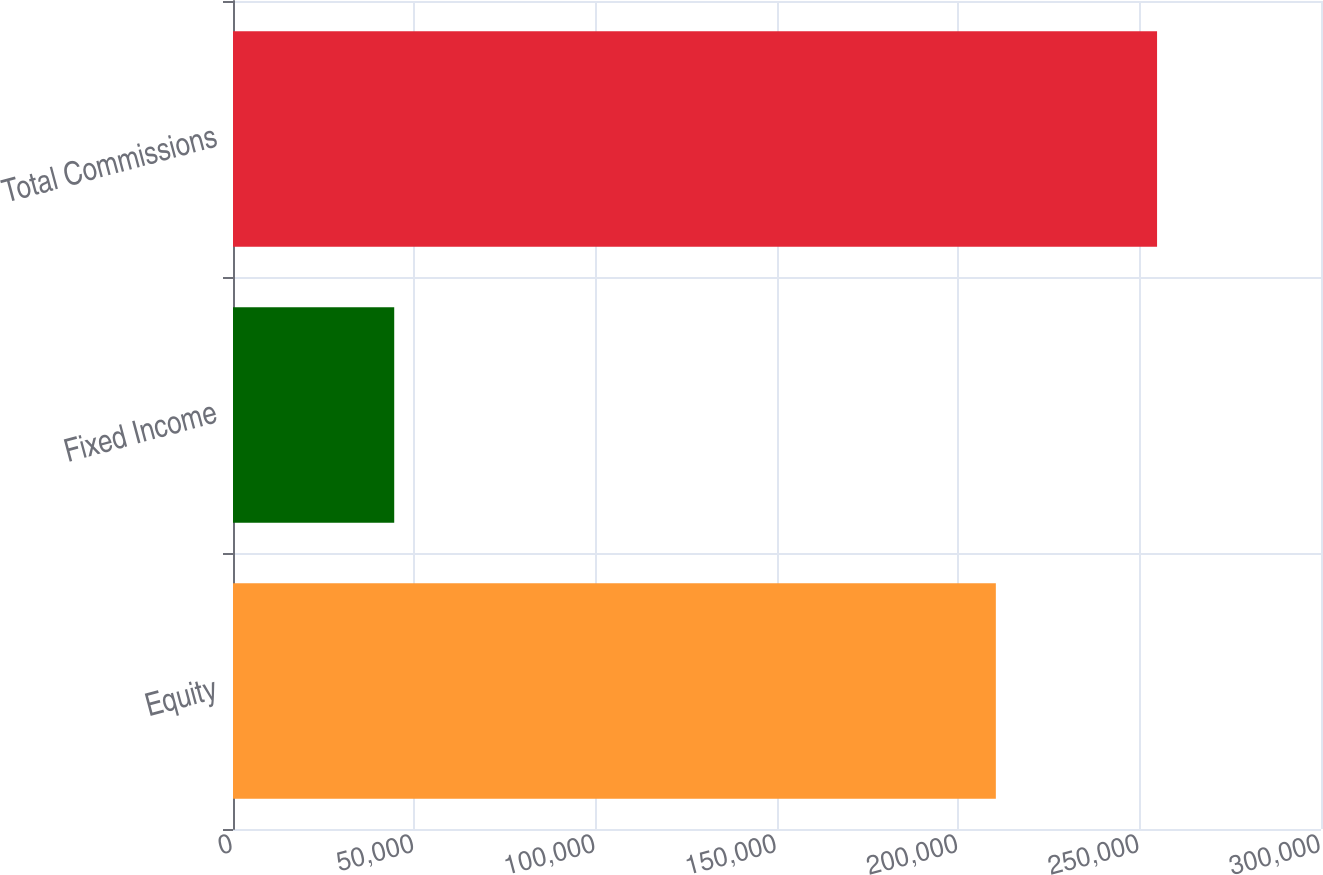Convert chart to OTSL. <chart><loc_0><loc_0><loc_500><loc_500><bar_chart><fcel>Equity<fcel>Fixed Income<fcel>Total Commissions<nl><fcel>210343<fcel>44454<fcel>254797<nl></chart> 